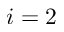<formula> <loc_0><loc_0><loc_500><loc_500>i = 2</formula> 